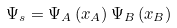Convert formula to latex. <formula><loc_0><loc_0><loc_500><loc_500>\Psi _ { s } = \Psi _ { A } \left ( x _ { A } \right ) \Psi _ { B } \left ( x _ { B } \right )</formula> 